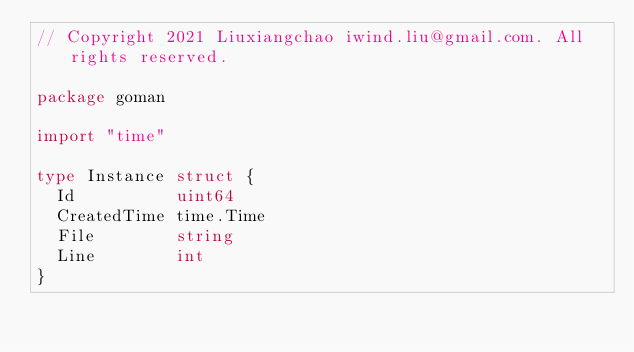Convert code to text. <code><loc_0><loc_0><loc_500><loc_500><_Go_>// Copyright 2021 Liuxiangchao iwind.liu@gmail.com. All rights reserved.

package goman

import "time"

type Instance struct {
	Id          uint64
	CreatedTime time.Time
	File        string
	Line        int
}
</code> 